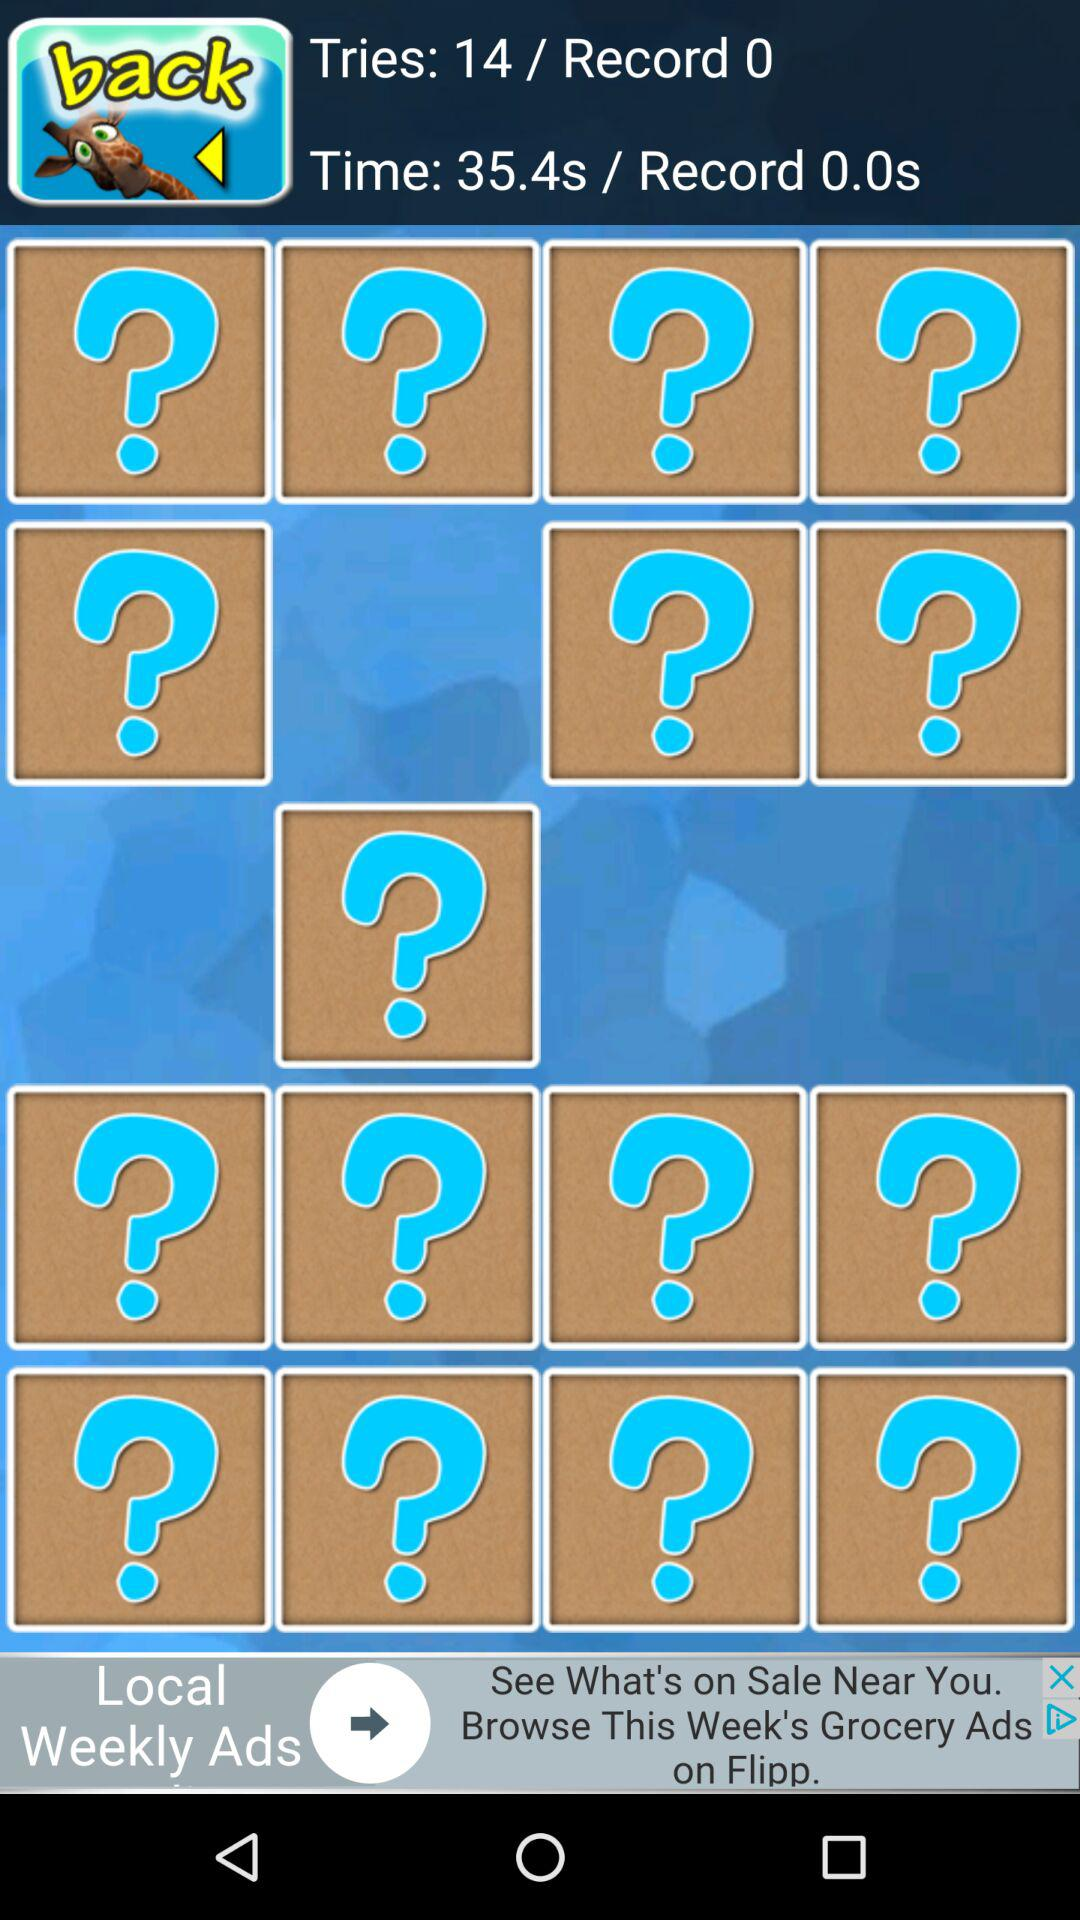How many seconds is the record time for this activity?
Answer the question using a single word or phrase. 0.0 